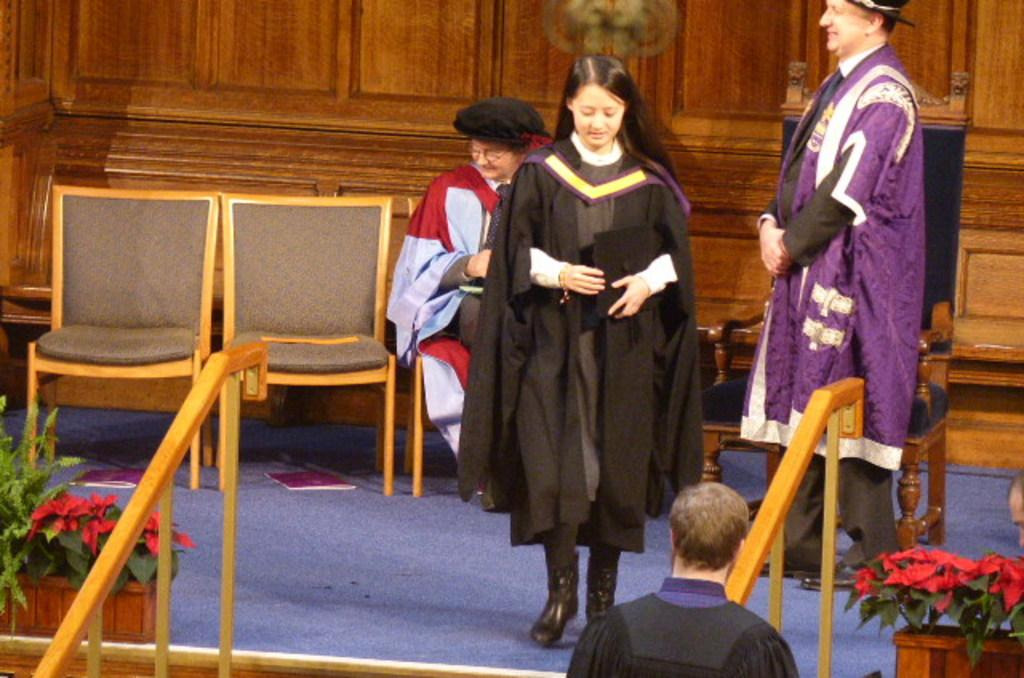How many people are in the image? There are people in the image, but the exact number is not specified. What are the people doing in the image? One person is sitting, and the rest of the people are standing. What can be seen in the image besides the people? There are plants and chairs in the image. What type of rice is being served on the table in the image? There is no table or rice present in the image. How many lettuce leaves are visible on the plants in the image? There are plants in the image, but no lettuce leaves are visible. 